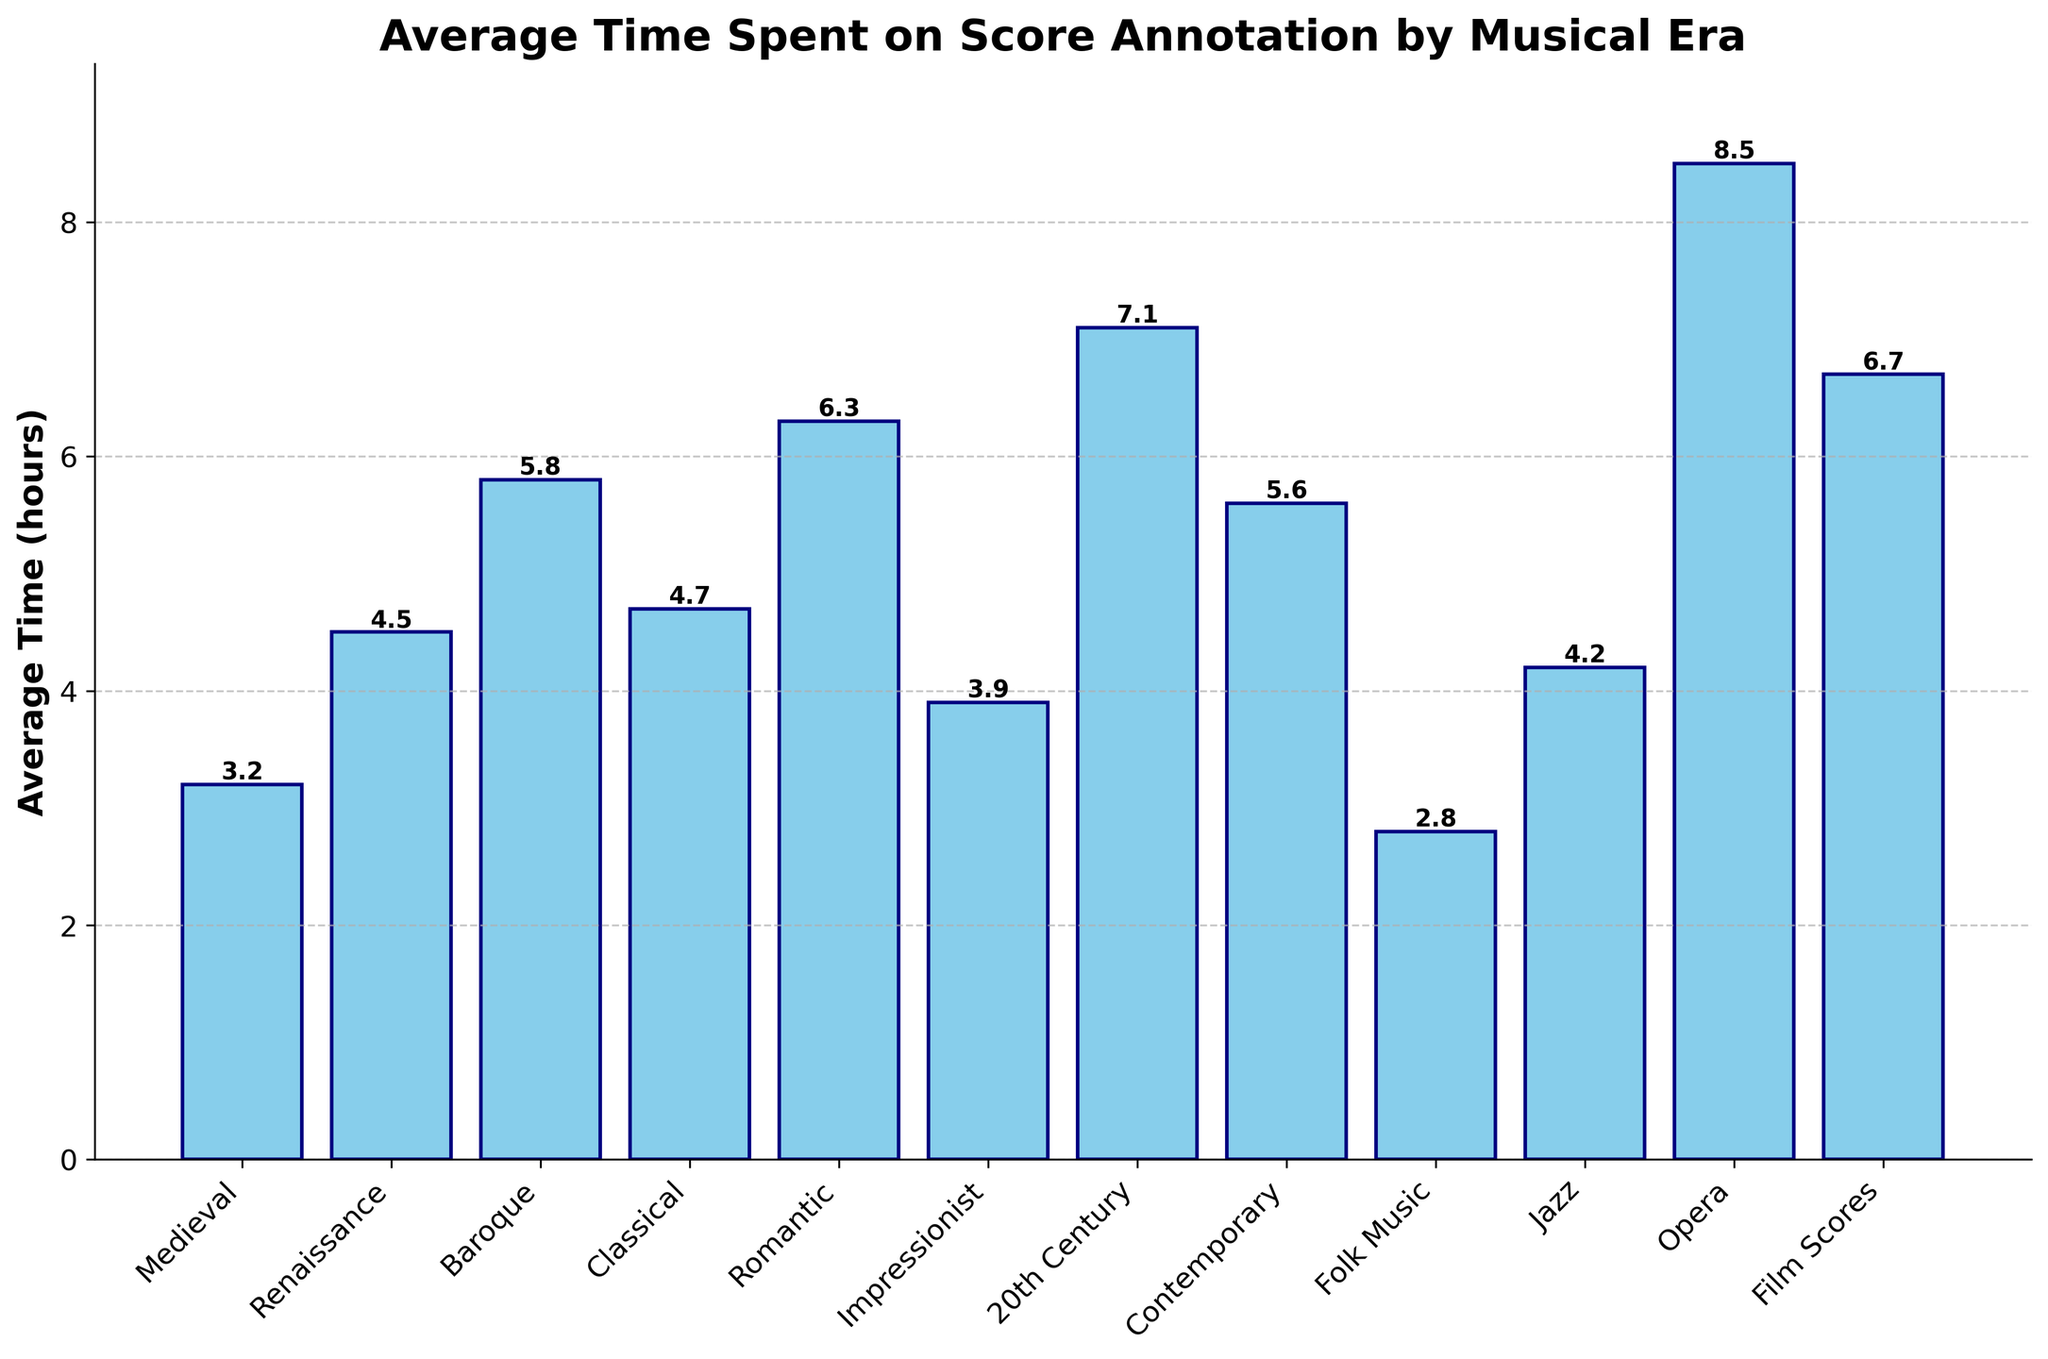Which musical era has the highest average time spent on score annotation? By observing the heights of the bars and their corresponding labels, we notice the "Opera" era has the tallest bar, indicating the highest average time spent on score annotation.
Answer: Opera What is the combined average time spent on score annotation for the Romantic and Contemporary eras? The average times for the Romantic and Contemporary eras are 6.3 and 5.6 hours, respectively. Adding these together: 6.3 + 5.6 = 11.9 hours.
Answer: 11.9 hours Which musical era requires more average time for score annotation, Baroque or Classical? Comparing the heights of the bars, the Baroque era has an average time of 5.8 hours whereas the Classical era has 4.7 hours. Since 5.8 is greater than 4.7, Baroque requires more average time.
Answer: Baroque What is the difference in the average annotation time between Opera and Folk Music? The Opera era's bar shows an average time of 8.5 hours, while Folk Music shows 2.8 hours. Subtracting these: 8.5 - 2.8 = 5.7 hours.
Answer: 5.7 hours Which era has the lowest average time spent on score annotation? Observing the bars, the "Folk Music" era has the shortest bar, indicating the lowest average time spent.
Answer: Folk Music What is the average annotation time taken for all eras combined? Adding the average times of all eras: 3.2 + 4.5 + 5.8 + 4.7 + 6.3 + 3.9 + 7.1 + 5.6 + 2.8 + 4.2 + 8.5 + 6.7 = 63.3 hours. Dividing by the number of eras (12): 63.3 / 12 = 5.275 hours.
Answer: 5.3 hours (approximately) Are there any musical eras where the average time spent on score annotation is below 4 hours? If so, which? Looking at the bars, the eras below 4 hours are Medieval (3.2 hours), Impressionist (3.9 hours), and Folk Music (2.8 hours).
Answer: Medieval, Impressionist, Folk Music How much higher is the average time spent on score annotation in the 20th Century era compared to the Baroque era? The 20th Century era shows an average time of 7.1 hours, while the Baroque era shows 5.8 hours. Subtracting these: 7.1 - 5.8 = 1.3 hours.
Answer: 1.3 hours Which two adjacent eras in the plot have the smallest difference in average annotation time? Observing the adjacent bars, "Jazz" (4.2 hours) and "Impressionist" (3.9 hours) have a difference of 0.3 hours, the smallest among observed differences.
Answer: Jazz and Impressionist What’s the range (difference between the highest and lowest values) of the average annotation times across all musical eras? The highest average time is for "Opera" (8.5 hours) and the lowest is for "Folk Music" (2.8 hours). Subtracting these: 8.5 - 2.8 = 5.7 hours.
Answer: 5.7 hours 